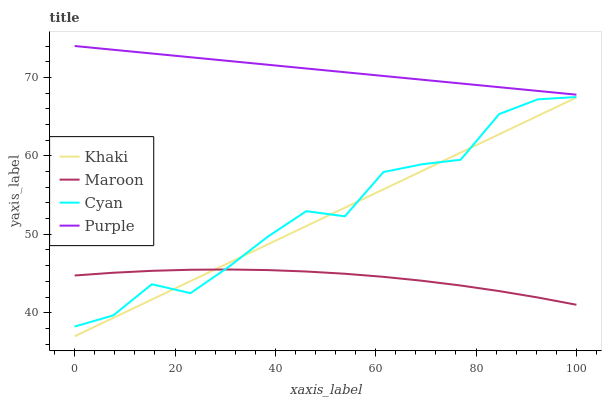Does Cyan have the minimum area under the curve?
Answer yes or no. No. Does Cyan have the maximum area under the curve?
Answer yes or no. No. Is Khaki the smoothest?
Answer yes or no. No. Is Khaki the roughest?
Answer yes or no. No. Does Cyan have the lowest value?
Answer yes or no. No. Does Cyan have the highest value?
Answer yes or no. No. Is Maroon less than Purple?
Answer yes or no. Yes. Is Purple greater than Cyan?
Answer yes or no. Yes. Does Maroon intersect Purple?
Answer yes or no. No. 